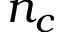<formula> <loc_0><loc_0><loc_500><loc_500>n _ { c }</formula> 